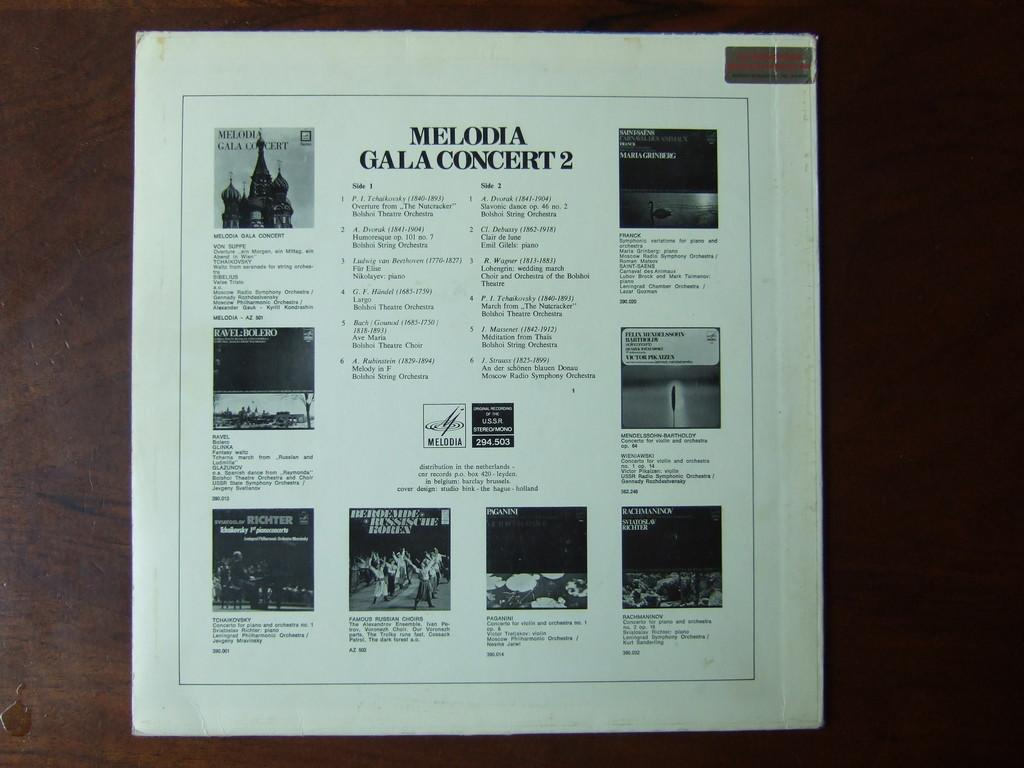<image>
Render a clear and concise summary of the photo. A white vinyl record says Melodia Gala Concert 2. 